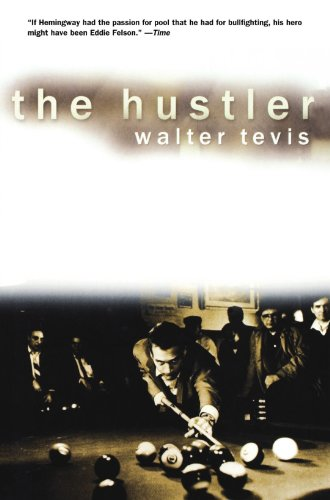Is this book related to Sports & Outdoors? Yes, 'The Hustler' relates to Sports & Outdoors through its exploration of billiards as a major element of the story, though it is more deeply a psychological drama than a straightforward sports novel. 